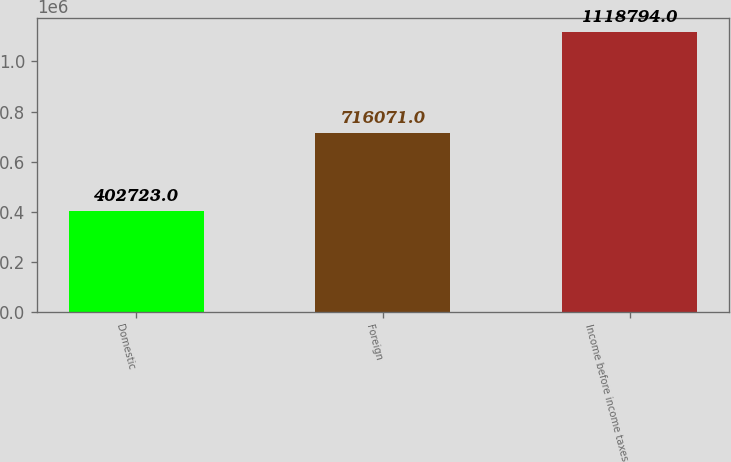Convert chart. <chart><loc_0><loc_0><loc_500><loc_500><bar_chart><fcel>Domestic<fcel>Foreign<fcel>Income before income taxes<nl><fcel>402723<fcel>716071<fcel>1.11879e+06<nl></chart> 